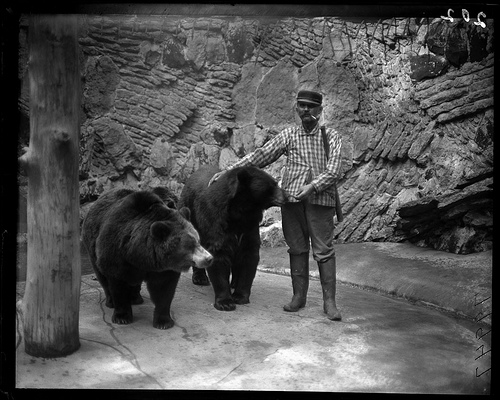Can you tell me more about the person in the picture? The person looks to be handling the bears confidently, suggesting that they might be a trainer or caretaker. They are dressed in a long-sleeve plaid shirt, trousers, and boots which implies a practical attire for the task at hand. 